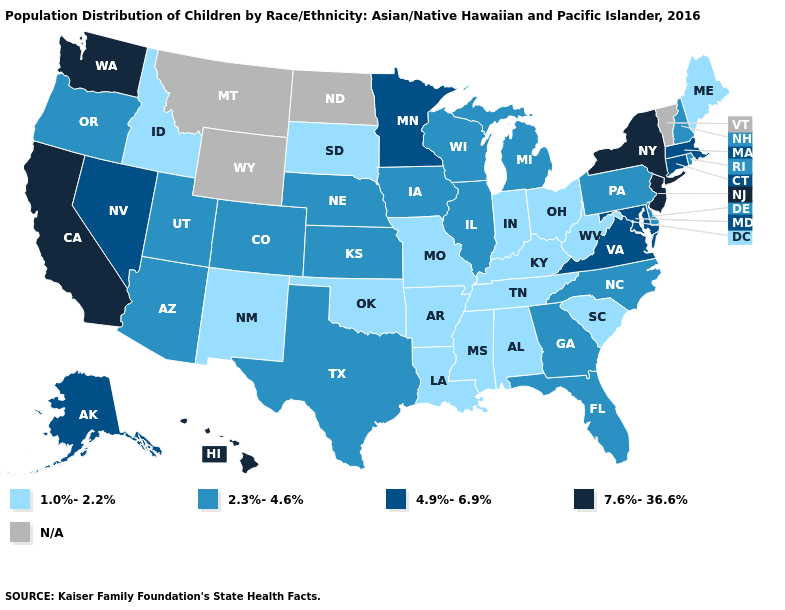Name the states that have a value in the range 2.3%-4.6%?
Be succinct. Arizona, Colorado, Delaware, Florida, Georgia, Illinois, Iowa, Kansas, Michigan, Nebraska, New Hampshire, North Carolina, Oregon, Pennsylvania, Rhode Island, Texas, Utah, Wisconsin. What is the value of Wyoming?
Concise answer only. N/A. Name the states that have a value in the range 4.9%-6.9%?
Write a very short answer. Alaska, Connecticut, Maryland, Massachusetts, Minnesota, Nevada, Virginia. Does the map have missing data?
Be succinct. Yes. Does Maine have the lowest value in the Northeast?
Keep it brief. Yes. What is the value of Nevada?
Answer briefly. 4.9%-6.9%. Name the states that have a value in the range 2.3%-4.6%?
Write a very short answer. Arizona, Colorado, Delaware, Florida, Georgia, Illinois, Iowa, Kansas, Michigan, Nebraska, New Hampshire, North Carolina, Oregon, Pennsylvania, Rhode Island, Texas, Utah, Wisconsin. What is the highest value in states that border Idaho?
Concise answer only. 7.6%-36.6%. What is the lowest value in states that border Iowa?
Concise answer only. 1.0%-2.2%. Name the states that have a value in the range 7.6%-36.6%?
Quick response, please. California, Hawaii, New Jersey, New York, Washington. What is the lowest value in the MidWest?
Be succinct. 1.0%-2.2%. What is the highest value in the MidWest ?
Concise answer only. 4.9%-6.9%. 